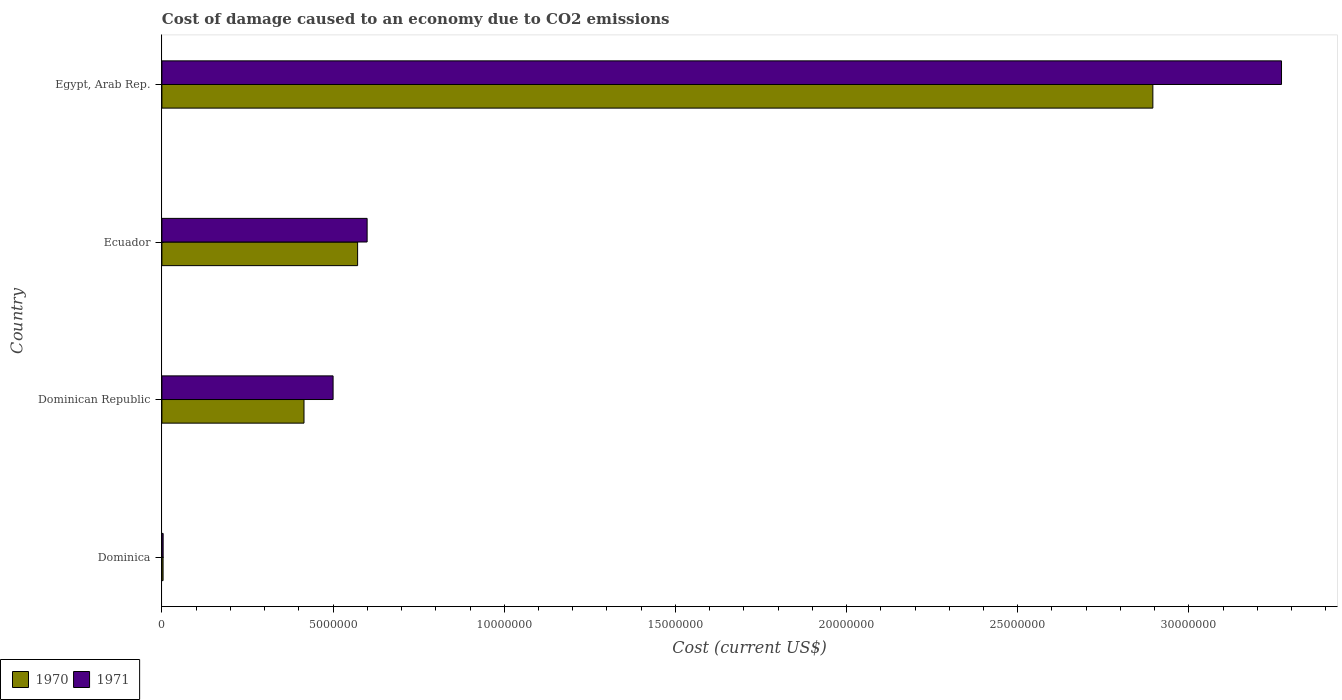How many different coloured bars are there?
Your response must be concise. 2. How many groups of bars are there?
Offer a terse response. 4. Are the number of bars per tick equal to the number of legend labels?
Your response must be concise. Yes. Are the number of bars on each tick of the Y-axis equal?
Keep it short and to the point. Yes. How many bars are there on the 2nd tick from the top?
Make the answer very short. 2. How many bars are there on the 4th tick from the bottom?
Your answer should be very brief. 2. What is the label of the 2nd group of bars from the top?
Offer a very short reply. Ecuador. What is the cost of damage caused due to CO2 emissisons in 1971 in Ecuador?
Your response must be concise. 5.99e+06. Across all countries, what is the maximum cost of damage caused due to CO2 emissisons in 1970?
Your answer should be very brief. 2.89e+07. Across all countries, what is the minimum cost of damage caused due to CO2 emissisons in 1970?
Give a very brief answer. 3.43e+04. In which country was the cost of damage caused due to CO2 emissisons in 1970 maximum?
Make the answer very short. Egypt, Arab Rep. In which country was the cost of damage caused due to CO2 emissisons in 1970 minimum?
Your answer should be very brief. Dominica. What is the total cost of damage caused due to CO2 emissisons in 1971 in the graph?
Keep it short and to the point. 4.37e+07. What is the difference between the cost of damage caused due to CO2 emissisons in 1970 in Dominica and that in Dominican Republic?
Your answer should be compact. -4.12e+06. What is the difference between the cost of damage caused due to CO2 emissisons in 1971 in Ecuador and the cost of damage caused due to CO2 emissisons in 1970 in Dominican Republic?
Give a very brief answer. 1.84e+06. What is the average cost of damage caused due to CO2 emissisons in 1970 per country?
Keep it short and to the point. 9.71e+06. What is the difference between the cost of damage caused due to CO2 emissisons in 1971 and cost of damage caused due to CO2 emissisons in 1970 in Egypt, Arab Rep.?
Provide a short and direct response. 3.76e+06. What is the ratio of the cost of damage caused due to CO2 emissisons in 1971 in Dominican Republic to that in Egypt, Arab Rep.?
Give a very brief answer. 0.15. Is the cost of damage caused due to CO2 emissisons in 1971 in Dominica less than that in Egypt, Arab Rep.?
Give a very brief answer. Yes. Is the difference between the cost of damage caused due to CO2 emissisons in 1971 in Ecuador and Egypt, Arab Rep. greater than the difference between the cost of damage caused due to CO2 emissisons in 1970 in Ecuador and Egypt, Arab Rep.?
Provide a short and direct response. No. What is the difference between the highest and the second highest cost of damage caused due to CO2 emissisons in 1971?
Offer a very short reply. 2.67e+07. What is the difference between the highest and the lowest cost of damage caused due to CO2 emissisons in 1970?
Provide a succinct answer. 2.89e+07. What does the 2nd bar from the top in Egypt, Arab Rep. represents?
Your answer should be very brief. 1970. What does the 1st bar from the bottom in Egypt, Arab Rep. represents?
Give a very brief answer. 1970. Are all the bars in the graph horizontal?
Offer a terse response. Yes. How many countries are there in the graph?
Provide a succinct answer. 4. Does the graph contain any zero values?
Make the answer very short. No. How many legend labels are there?
Your answer should be very brief. 2. How are the legend labels stacked?
Ensure brevity in your answer.  Horizontal. What is the title of the graph?
Offer a terse response. Cost of damage caused to an economy due to CO2 emissions. What is the label or title of the X-axis?
Offer a terse response. Cost (current US$). What is the label or title of the Y-axis?
Your answer should be compact. Country. What is the Cost (current US$) of 1970 in Dominica?
Your answer should be very brief. 3.43e+04. What is the Cost (current US$) in 1971 in Dominica?
Offer a terse response. 3.64e+04. What is the Cost (current US$) in 1970 in Dominican Republic?
Your answer should be compact. 4.15e+06. What is the Cost (current US$) in 1971 in Dominican Republic?
Offer a terse response. 5.00e+06. What is the Cost (current US$) in 1970 in Ecuador?
Your answer should be compact. 5.72e+06. What is the Cost (current US$) of 1971 in Ecuador?
Your answer should be compact. 5.99e+06. What is the Cost (current US$) in 1970 in Egypt, Arab Rep.?
Offer a terse response. 2.89e+07. What is the Cost (current US$) in 1971 in Egypt, Arab Rep.?
Provide a succinct answer. 3.27e+07. Across all countries, what is the maximum Cost (current US$) of 1970?
Provide a succinct answer. 2.89e+07. Across all countries, what is the maximum Cost (current US$) in 1971?
Provide a succinct answer. 3.27e+07. Across all countries, what is the minimum Cost (current US$) in 1970?
Ensure brevity in your answer.  3.43e+04. Across all countries, what is the minimum Cost (current US$) in 1971?
Your answer should be very brief. 3.64e+04. What is the total Cost (current US$) of 1970 in the graph?
Your answer should be compact. 3.88e+07. What is the total Cost (current US$) in 1971 in the graph?
Make the answer very short. 4.37e+07. What is the difference between the Cost (current US$) of 1970 in Dominica and that in Dominican Republic?
Keep it short and to the point. -4.12e+06. What is the difference between the Cost (current US$) of 1971 in Dominica and that in Dominican Republic?
Offer a terse response. -4.96e+06. What is the difference between the Cost (current US$) of 1970 in Dominica and that in Ecuador?
Give a very brief answer. -5.68e+06. What is the difference between the Cost (current US$) of 1971 in Dominica and that in Ecuador?
Ensure brevity in your answer.  -5.96e+06. What is the difference between the Cost (current US$) in 1970 in Dominica and that in Egypt, Arab Rep.?
Offer a very short reply. -2.89e+07. What is the difference between the Cost (current US$) in 1971 in Dominica and that in Egypt, Arab Rep.?
Offer a very short reply. -3.27e+07. What is the difference between the Cost (current US$) in 1970 in Dominican Republic and that in Ecuador?
Ensure brevity in your answer.  -1.57e+06. What is the difference between the Cost (current US$) of 1971 in Dominican Republic and that in Ecuador?
Give a very brief answer. -9.94e+05. What is the difference between the Cost (current US$) in 1970 in Dominican Republic and that in Egypt, Arab Rep.?
Your answer should be compact. -2.48e+07. What is the difference between the Cost (current US$) of 1971 in Dominican Republic and that in Egypt, Arab Rep.?
Offer a terse response. -2.77e+07. What is the difference between the Cost (current US$) in 1970 in Ecuador and that in Egypt, Arab Rep.?
Your response must be concise. -2.32e+07. What is the difference between the Cost (current US$) of 1971 in Ecuador and that in Egypt, Arab Rep.?
Provide a short and direct response. -2.67e+07. What is the difference between the Cost (current US$) of 1970 in Dominica and the Cost (current US$) of 1971 in Dominican Republic?
Your response must be concise. -4.97e+06. What is the difference between the Cost (current US$) of 1970 in Dominica and the Cost (current US$) of 1971 in Ecuador?
Give a very brief answer. -5.96e+06. What is the difference between the Cost (current US$) of 1970 in Dominica and the Cost (current US$) of 1971 in Egypt, Arab Rep.?
Your response must be concise. -3.27e+07. What is the difference between the Cost (current US$) in 1970 in Dominican Republic and the Cost (current US$) in 1971 in Ecuador?
Your answer should be very brief. -1.84e+06. What is the difference between the Cost (current US$) of 1970 in Dominican Republic and the Cost (current US$) of 1971 in Egypt, Arab Rep.?
Ensure brevity in your answer.  -2.86e+07. What is the difference between the Cost (current US$) of 1970 in Ecuador and the Cost (current US$) of 1971 in Egypt, Arab Rep.?
Provide a short and direct response. -2.70e+07. What is the average Cost (current US$) of 1970 per country?
Give a very brief answer. 9.71e+06. What is the average Cost (current US$) in 1971 per country?
Your answer should be compact. 1.09e+07. What is the difference between the Cost (current US$) of 1970 and Cost (current US$) of 1971 in Dominica?
Offer a terse response. -2162.9. What is the difference between the Cost (current US$) of 1970 and Cost (current US$) of 1971 in Dominican Republic?
Your response must be concise. -8.50e+05. What is the difference between the Cost (current US$) of 1970 and Cost (current US$) of 1971 in Ecuador?
Provide a succinct answer. -2.78e+05. What is the difference between the Cost (current US$) of 1970 and Cost (current US$) of 1971 in Egypt, Arab Rep.?
Give a very brief answer. -3.76e+06. What is the ratio of the Cost (current US$) of 1970 in Dominica to that in Dominican Republic?
Ensure brevity in your answer.  0.01. What is the ratio of the Cost (current US$) in 1971 in Dominica to that in Dominican Republic?
Provide a short and direct response. 0.01. What is the ratio of the Cost (current US$) in 1970 in Dominica to that in Ecuador?
Keep it short and to the point. 0.01. What is the ratio of the Cost (current US$) of 1971 in Dominica to that in Ecuador?
Ensure brevity in your answer.  0.01. What is the ratio of the Cost (current US$) in 1970 in Dominica to that in Egypt, Arab Rep.?
Offer a very short reply. 0. What is the ratio of the Cost (current US$) in 1971 in Dominica to that in Egypt, Arab Rep.?
Provide a short and direct response. 0. What is the ratio of the Cost (current US$) in 1970 in Dominican Republic to that in Ecuador?
Give a very brief answer. 0.73. What is the ratio of the Cost (current US$) in 1971 in Dominican Republic to that in Ecuador?
Your answer should be compact. 0.83. What is the ratio of the Cost (current US$) of 1970 in Dominican Republic to that in Egypt, Arab Rep.?
Your answer should be compact. 0.14. What is the ratio of the Cost (current US$) of 1971 in Dominican Republic to that in Egypt, Arab Rep.?
Offer a very short reply. 0.15. What is the ratio of the Cost (current US$) in 1970 in Ecuador to that in Egypt, Arab Rep.?
Provide a succinct answer. 0.2. What is the ratio of the Cost (current US$) in 1971 in Ecuador to that in Egypt, Arab Rep.?
Offer a very short reply. 0.18. What is the difference between the highest and the second highest Cost (current US$) in 1970?
Ensure brevity in your answer.  2.32e+07. What is the difference between the highest and the second highest Cost (current US$) in 1971?
Your answer should be very brief. 2.67e+07. What is the difference between the highest and the lowest Cost (current US$) of 1970?
Keep it short and to the point. 2.89e+07. What is the difference between the highest and the lowest Cost (current US$) of 1971?
Provide a succinct answer. 3.27e+07. 